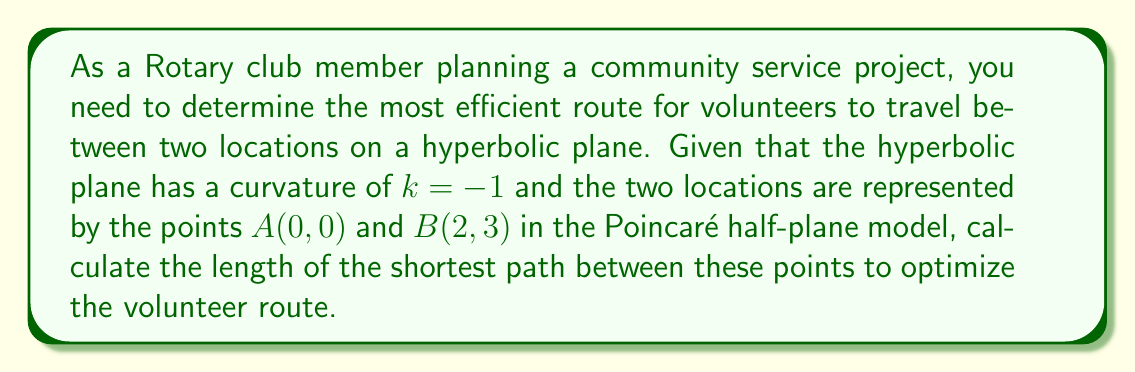Can you solve this math problem? To solve this problem, we'll follow these steps:

1) In the Poincaré half-plane model of hyperbolic geometry, the shortest path between two points is represented by either a vertical line or a semicircle orthogonal to the x-axis.

2) Given that our points are not vertically aligned, we'll use the semicircle method.

3) The general equation for a semicircle in the Poincaré half-plane model is:

   $$(x - a)^2 + y^2 = r^2$$

   where $(a, 0)$ is the center of the semicircle on the x-axis, and $r$ is its radius.

4) To find $a$ and $r$, we use the fact that the semicircle passes through both $A(0, 0)$ and $B(2, 3)$:

   $$(0 - a)^2 + 0^2 = r^2$$
   $$(2 - a)^2 + 3^2 = r^2$$

5) Solving these equations:

   $a^2 = r^2$
   $(2-a)^2 + 9 = r^2$

6) Subtracting the first equation from the second:

   $4 - 4a + 9 = 0$
   $4a = 13$
   $a = \frac{13}{4}$

7) Substituting back:

   $r^2 = (\frac{13}{4})^2 = \frac{169}{16}$

8) The length of the geodesic (shortest path) in the Poincaré half-plane model is given by:

   $$d = \ln\left(\frac{|z_2 - z_1^*|+|z_2 - z_1|}{|z_2 - z_1^*|-|z_2 - z_1|}\right)$$

   where $z_1 = x_1 + iy_1$ and $z_2 = x_2 + iy_2$ are the complex representations of the two points, and $z_1^*$ is the complex conjugate of $z_1$.

9) In our case:
   $z_1 = 0 + 0i = 0$
   $z_2 = 2 + 3i$
   $z_1^* = 0$

10) Calculating:
    $|z_2 - z_1^*| = |2 + 3i| = \sqrt{13}$
    $|z_2 - z_1| = |2 + 3i| = \sqrt{13}$

11) Substituting into the formula:

    $$d = \ln\left(\frac{\sqrt{13}+\sqrt{13}}{\sqrt{13}-\sqrt{13}}\right) = \ln\left(\frac{2\sqrt{13}}{0}\right)$$

12) This results in an undefined value due to division by zero. However, we can interpret this geometrically: as the denominator approaches zero, the fraction approaches infinity, and the logarithm of infinity is infinity.

Therefore, the length of the shortest path is infinite in this hyperbolic plane.
Answer: The shortest path length is infinite. 